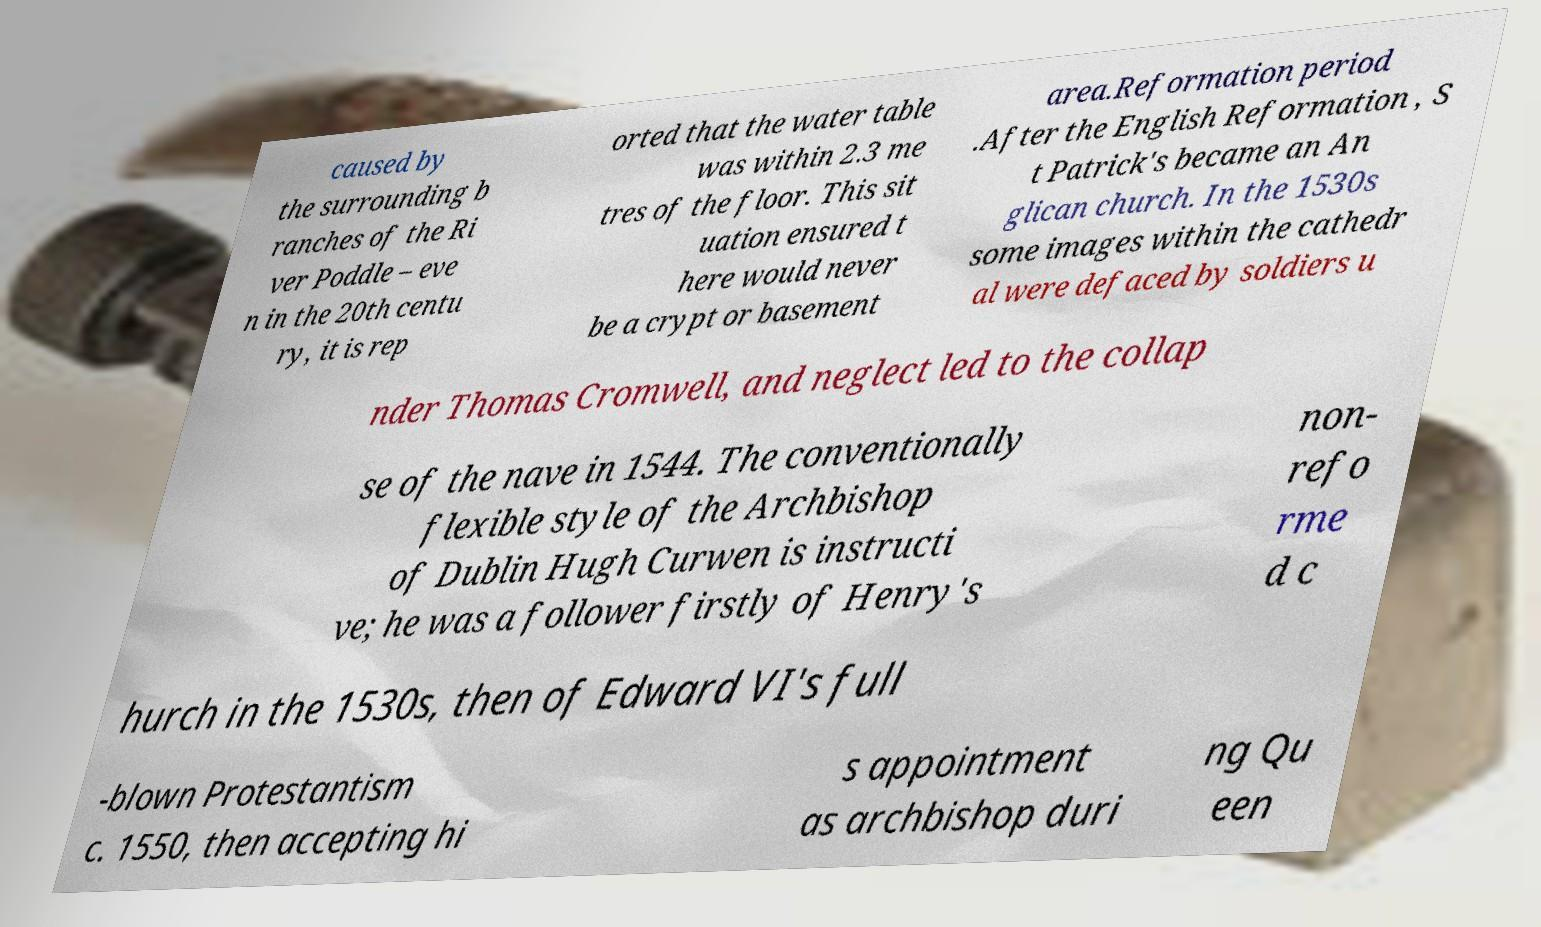Could you extract and type out the text from this image? caused by the surrounding b ranches of the Ri ver Poddle – eve n in the 20th centu ry, it is rep orted that the water table was within 2.3 me tres of the floor. This sit uation ensured t here would never be a crypt or basement area.Reformation period .After the English Reformation , S t Patrick's became an An glican church. In the 1530s some images within the cathedr al were defaced by soldiers u nder Thomas Cromwell, and neglect led to the collap se of the nave in 1544. The conventionally flexible style of the Archbishop of Dublin Hugh Curwen is instructi ve; he was a follower firstly of Henry's non- refo rme d c hurch in the 1530s, then of Edward VI's full -blown Protestantism c. 1550, then accepting hi s appointment as archbishop duri ng Qu een 